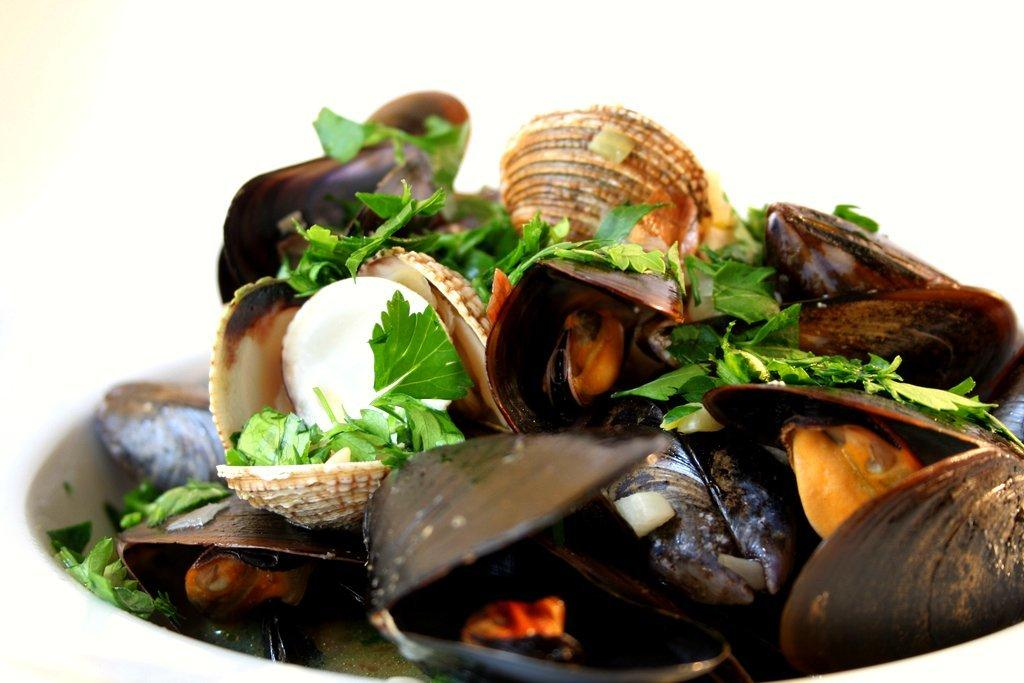What is in the bowl that is visible in the image? There are many shells in a bowl in the image. What is placed on top of the shells? There is mint on the shells. What type of food item is on the shells? There is a food item on the shells. Where is the glass located in the image? There is no glass present in the image. Can you see any ghosts in the image? There are no ghosts present in the image. 